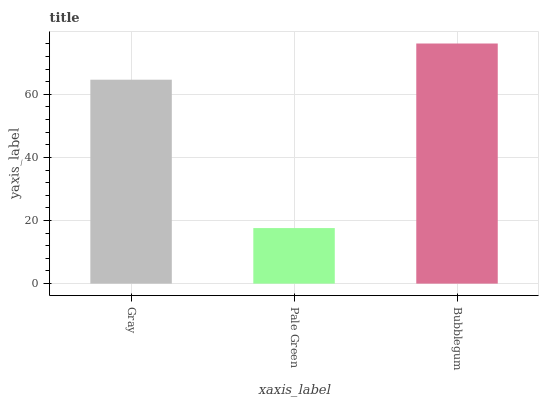Is Pale Green the minimum?
Answer yes or no. Yes. Is Bubblegum the maximum?
Answer yes or no. Yes. Is Bubblegum the minimum?
Answer yes or no. No. Is Pale Green the maximum?
Answer yes or no. No. Is Bubblegum greater than Pale Green?
Answer yes or no. Yes. Is Pale Green less than Bubblegum?
Answer yes or no. Yes. Is Pale Green greater than Bubblegum?
Answer yes or no. No. Is Bubblegum less than Pale Green?
Answer yes or no. No. Is Gray the high median?
Answer yes or no. Yes. Is Gray the low median?
Answer yes or no. Yes. Is Pale Green the high median?
Answer yes or no. No. Is Pale Green the low median?
Answer yes or no. No. 